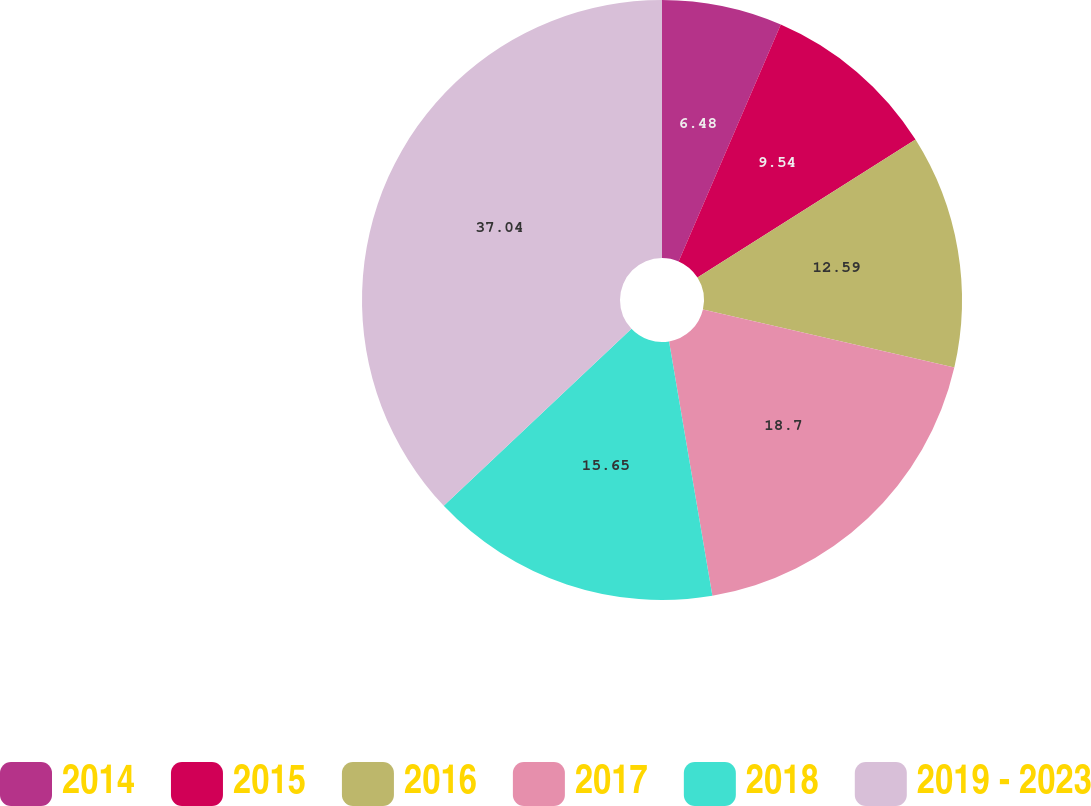Convert chart to OTSL. <chart><loc_0><loc_0><loc_500><loc_500><pie_chart><fcel>2014<fcel>2015<fcel>2016<fcel>2017<fcel>2018<fcel>2019 - 2023<nl><fcel>6.48%<fcel>9.54%<fcel>12.59%<fcel>18.7%<fcel>15.65%<fcel>37.03%<nl></chart> 